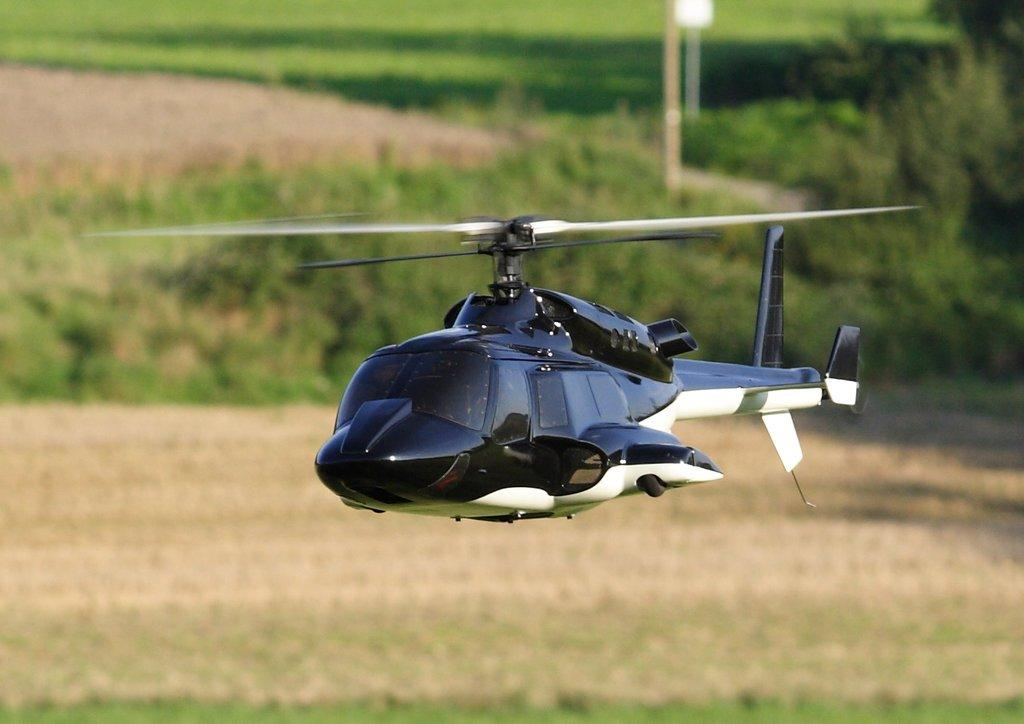What is the main subject of the image? The main subject of the image is a helicopter. What is the helicopter doing in the image? The helicopter is flying in the air. What color is the background of the image? The background of the image is blue. Can you see any nerves in the image? There are no nerves present in the image; it features a helicopter flying in the air with a blue background. 